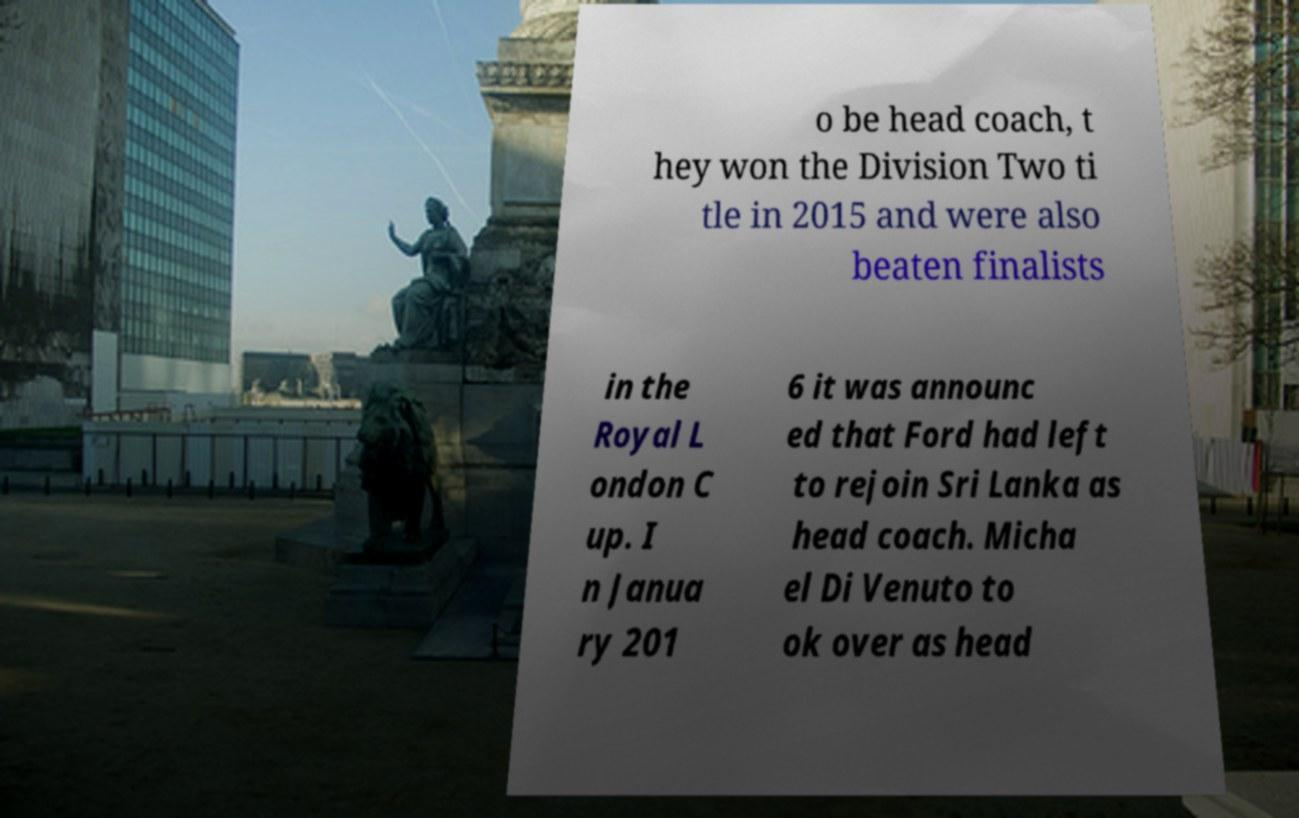I need the written content from this picture converted into text. Can you do that? o be head coach, t hey won the Division Two ti tle in 2015 and were also beaten finalists in the Royal L ondon C up. I n Janua ry 201 6 it was announc ed that Ford had left to rejoin Sri Lanka as head coach. Micha el Di Venuto to ok over as head 